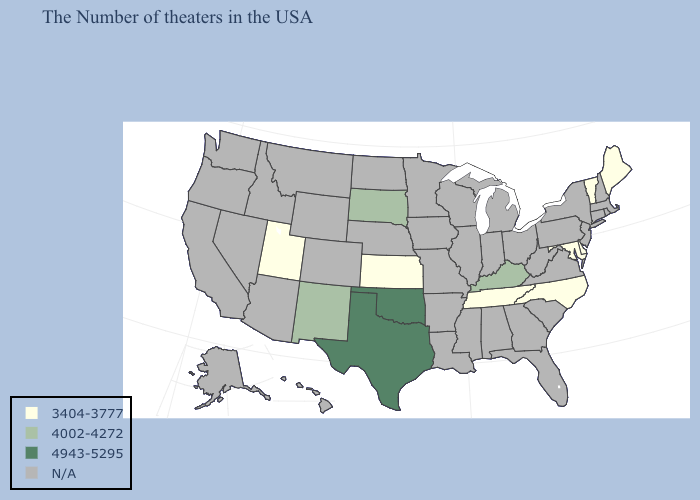What is the lowest value in the USA?
Write a very short answer. 3404-3777. Name the states that have a value in the range N/A?
Keep it brief. Massachusetts, Rhode Island, New Hampshire, Connecticut, New York, New Jersey, Pennsylvania, Virginia, South Carolina, West Virginia, Ohio, Florida, Georgia, Michigan, Indiana, Alabama, Wisconsin, Illinois, Mississippi, Louisiana, Missouri, Arkansas, Minnesota, Iowa, Nebraska, North Dakota, Wyoming, Colorado, Montana, Arizona, Idaho, Nevada, California, Washington, Oregon, Alaska, Hawaii. Name the states that have a value in the range 3404-3777?
Concise answer only. Maine, Vermont, Delaware, Maryland, North Carolina, Tennessee, Kansas, Utah. What is the value of Maryland?
Write a very short answer. 3404-3777. What is the value of North Carolina?
Write a very short answer. 3404-3777. What is the highest value in the USA?
Answer briefly. 4943-5295. Which states have the highest value in the USA?
Quick response, please. Oklahoma, Texas. Among the states that border Kansas , which have the lowest value?
Write a very short answer. Oklahoma. What is the value of Mississippi?
Concise answer only. N/A. Name the states that have a value in the range 4943-5295?
Concise answer only. Oklahoma, Texas. What is the value of New York?
Write a very short answer. N/A. Does the first symbol in the legend represent the smallest category?
Give a very brief answer. Yes. Does South Dakota have the highest value in the MidWest?
Answer briefly. Yes. 